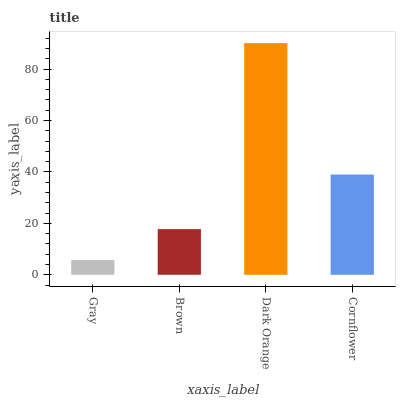Is Gray the minimum?
Answer yes or no. Yes. Is Dark Orange the maximum?
Answer yes or no. Yes. Is Brown the minimum?
Answer yes or no. No. Is Brown the maximum?
Answer yes or no. No. Is Brown greater than Gray?
Answer yes or no. Yes. Is Gray less than Brown?
Answer yes or no. Yes. Is Gray greater than Brown?
Answer yes or no. No. Is Brown less than Gray?
Answer yes or no. No. Is Cornflower the high median?
Answer yes or no. Yes. Is Brown the low median?
Answer yes or no. Yes. Is Gray the high median?
Answer yes or no. No. Is Gray the low median?
Answer yes or no. No. 